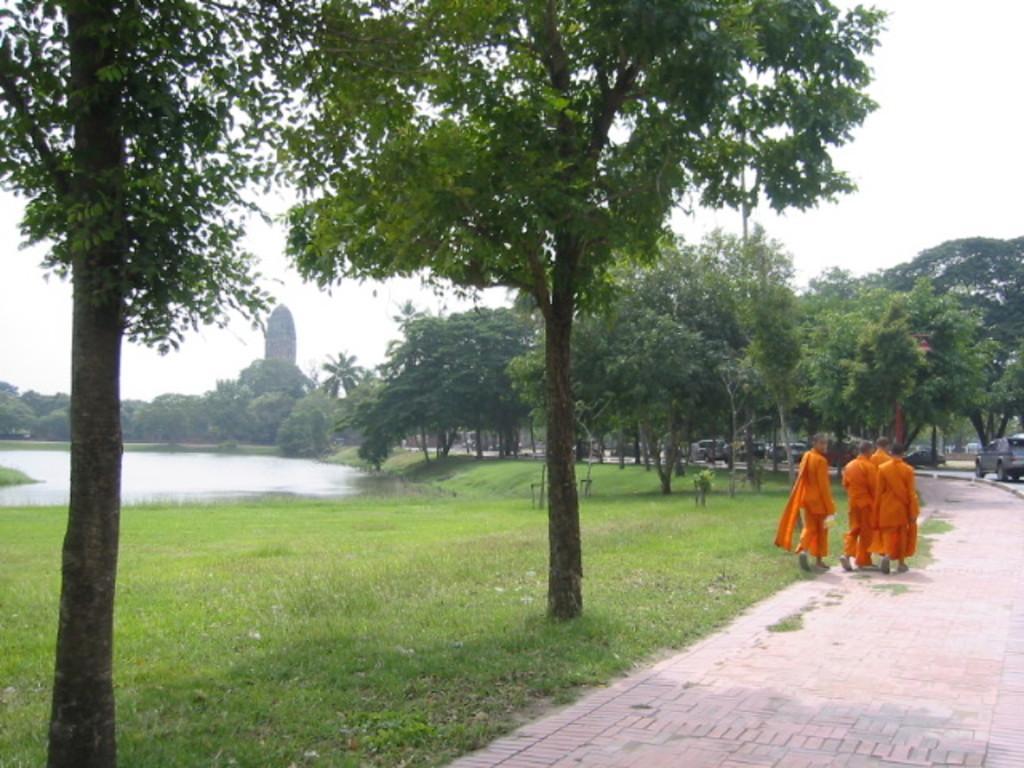Could you give a brief overview of what you see in this image? In this picture there are group of people on the right side of the image and there is grassland in the center of the image and there are cars, trees, and water in the background area of the image. 